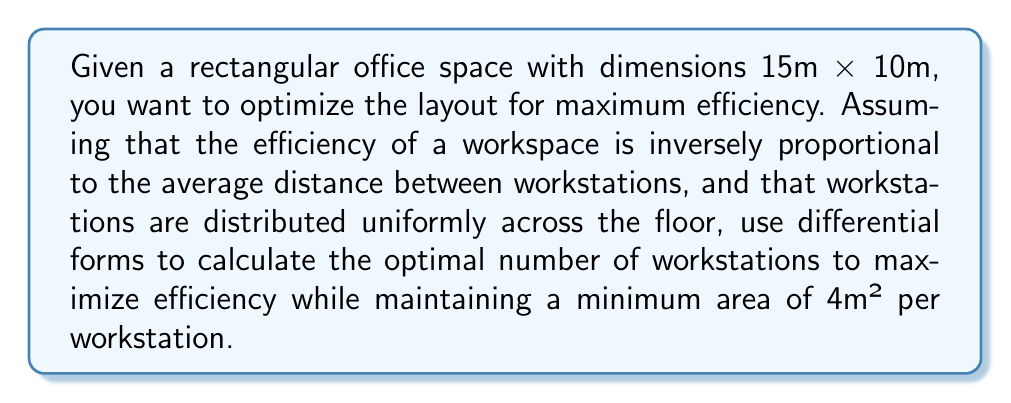Teach me how to tackle this problem. Let's approach this step-by-step using differential forms:

1) First, we need to define our 2-form representing the efficiency of the workspace. Let $\omega$ be this 2-form:

   $$\omega = \frac{1}{d} dx \wedge dy$$

   where $d$ is the average distance between workstations.

2) The total efficiency $E$ will be the integral of this form over the office space:

   $$E = \int_S \omega = \int_S \frac{1}{d} dx \wedge dy$$

3) To calculate $d$, we can use the fact that for $n$ uniformly distributed points in an area $A$, the average distance is approximately:

   $$d \approx \frac{1}{2}\sqrt{\frac{A}{n}}$$

4) Substituting this into our efficiency form:

   $$\omega = \frac{2\sqrt{n}}{\sqrt{A}} dx \wedge dy$$

5) Now, let's integrate this over our rectangular office space:

   $$E = \int_0^{10} \int_0^{15} \frac{2\sqrt{n}}{\sqrt{150}} dx dy = 30\sqrt{n}$$

6) We want to maximize $E$ subject to the constraint that each workstation has at least 4m² of space:

   $$\frac{150}{n} \geq 4$$

   $$n \leq 37.5$$

7) Since $n$ must be an integer, the maximum value it can take is 37.

8) To verify this is indeed the maximum, we can check the values of $E$ for $n = 36$ and $n = 37$:

   For $n = 36$: $E = 30\sqrt{36} = 180$
   For $n = 37$: $E = 30\sqrt{37} \approx 182.71$

Therefore, the optimal number of workstations is 37.
Answer: 37 workstations 